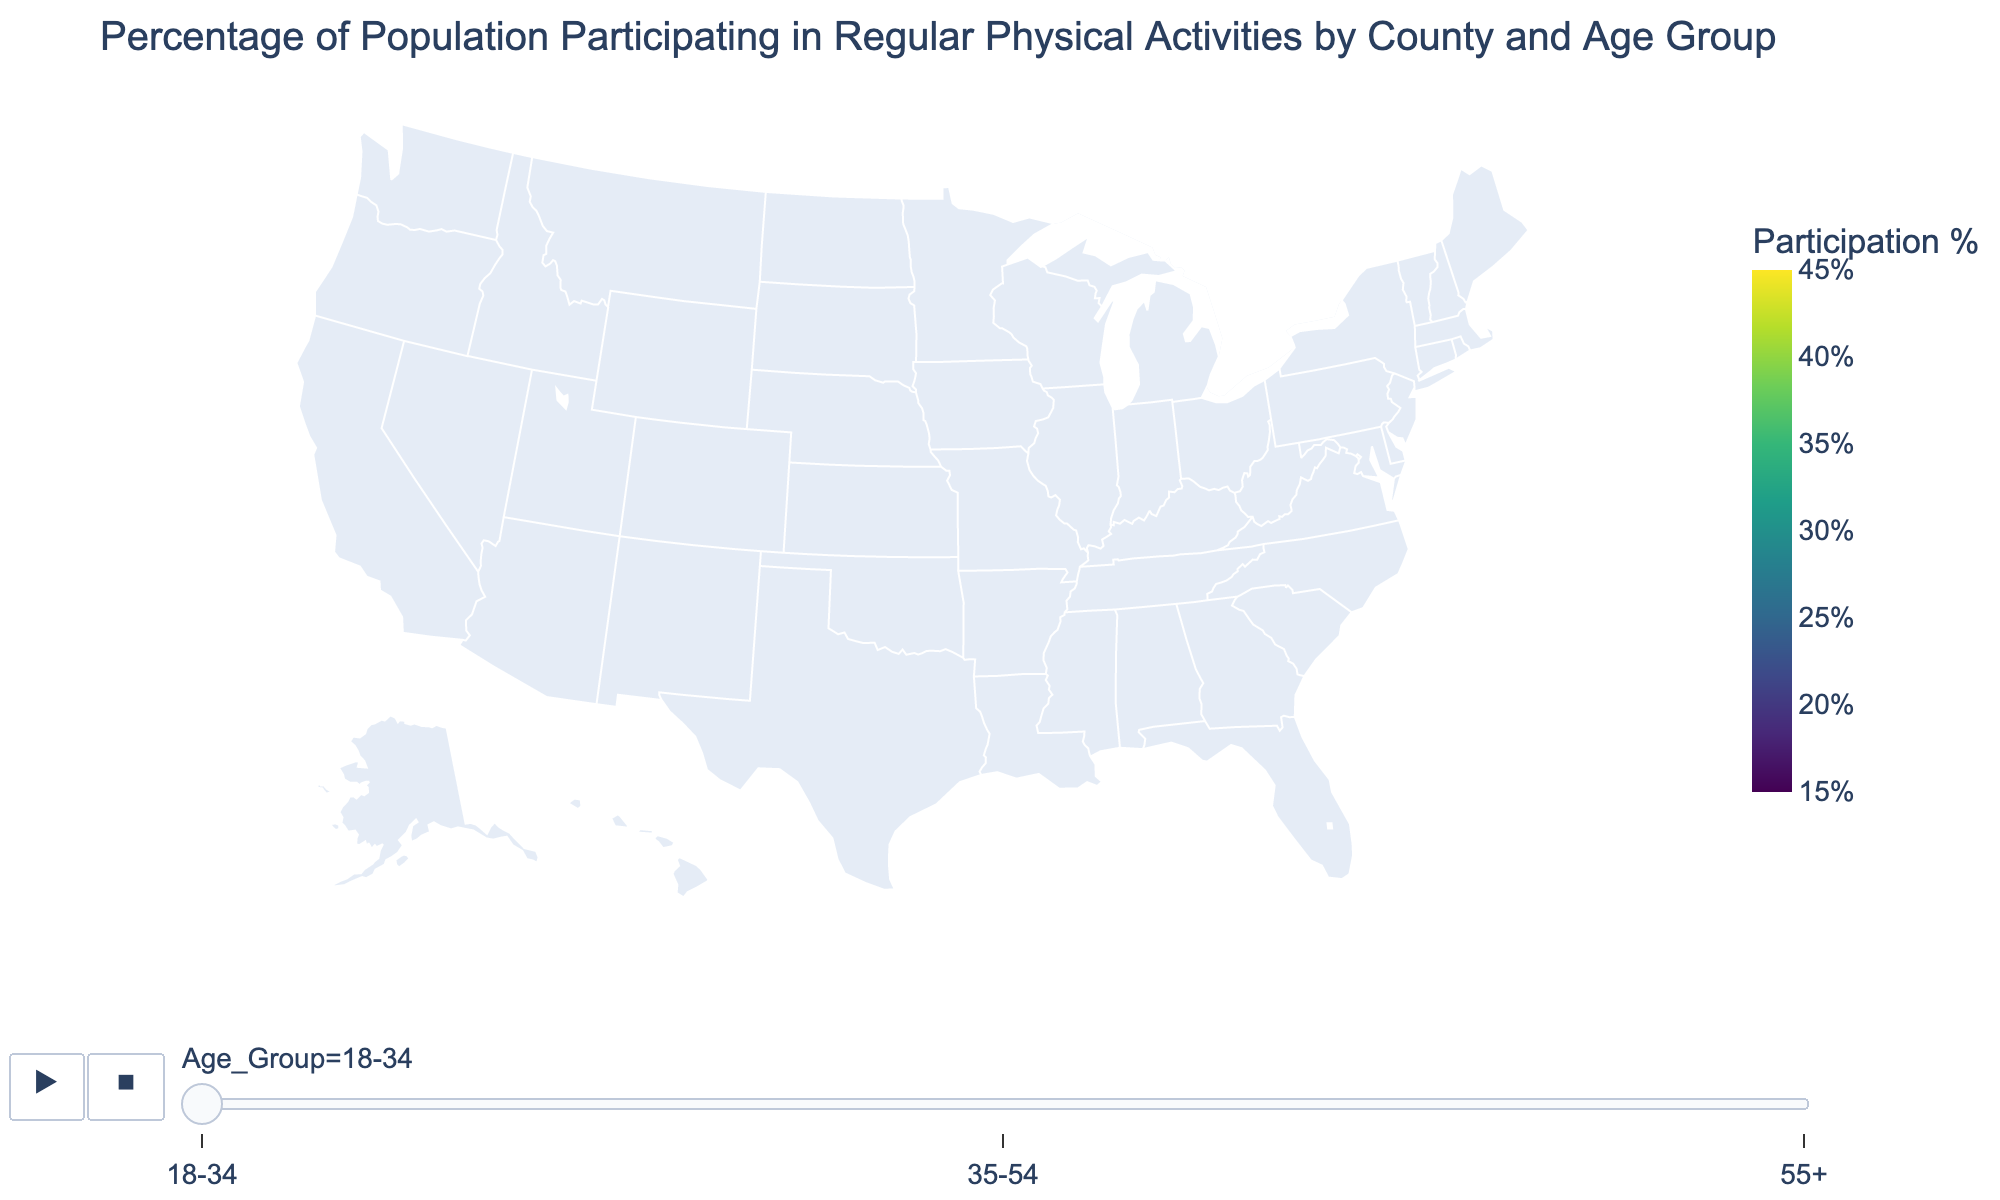What's the title of the plot? The title is usually placed at the top of the figure and summarizes the main topic of the visualization.
Answer: Percentage of Population Participating in Regular Physical Activities by County and Age Group Which county has the highest percentage of participation in the 18-34 age group? The plot shows different counties and their participation rates. We look for the highest value in the 18-34 age group.
Answer: King County What is the participation percentage for the 55+ age group in Miami-Dade County? Locate Miami-Dade County in the figure and find the value corresponding to the 55+ age group.
Answer: 23% Which county has the lowest participation percentage in the 35-54 age group? Compare the values for all counties in the 35-54 age group.
Answer: Wayne County What's the difference in participation percentage between the 18-34 and 55+ age groups in San Diego County? Subtract the 55+ percentage from the 18-34 percentage for San Diego County: 40% - 28% = 12%
Answer: 12% How does the participation rate for the 18-34 age group in Maricopa County compare to that in Orange County? Compare the percentages of the 18-34 age group for both counties: Maricopa County (38%) vs. Orange County (36%).
Answer: Maricopa County is higher Which age group shows the highest participation percentage overall? Compare the highest participation percentages among all age groups listed in the plot.
Answer: 18-34 age group What's the average participation percentage for the 35-54 age group across all counties? Add up all the percentages for the 35-54 age group and divide by the number of counties. Calculation: (28+26+31+33+35+32+29+30+37+32+36+31+29+25+34+27+34+31+28+33)/20 = 30.6%
Answer: 30.6% Which age group has the smallest range (difference between the highest and lowest values) of participation percentages across counties? Find the range for each age group by subtracting the lowest percentage from the highest for each age group.
Answer: 55+ age group 